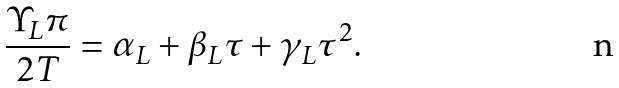Convert formula to latex. <formula><loc_0><loc_0><loc_500><loc_500>\frac { \Upsilon _ { L } \pi } { 2 T } = \alpha _ { L } + \beta _ { L } \tau + \gamma _ { L } \tau ^ { 2 } .</formula> 